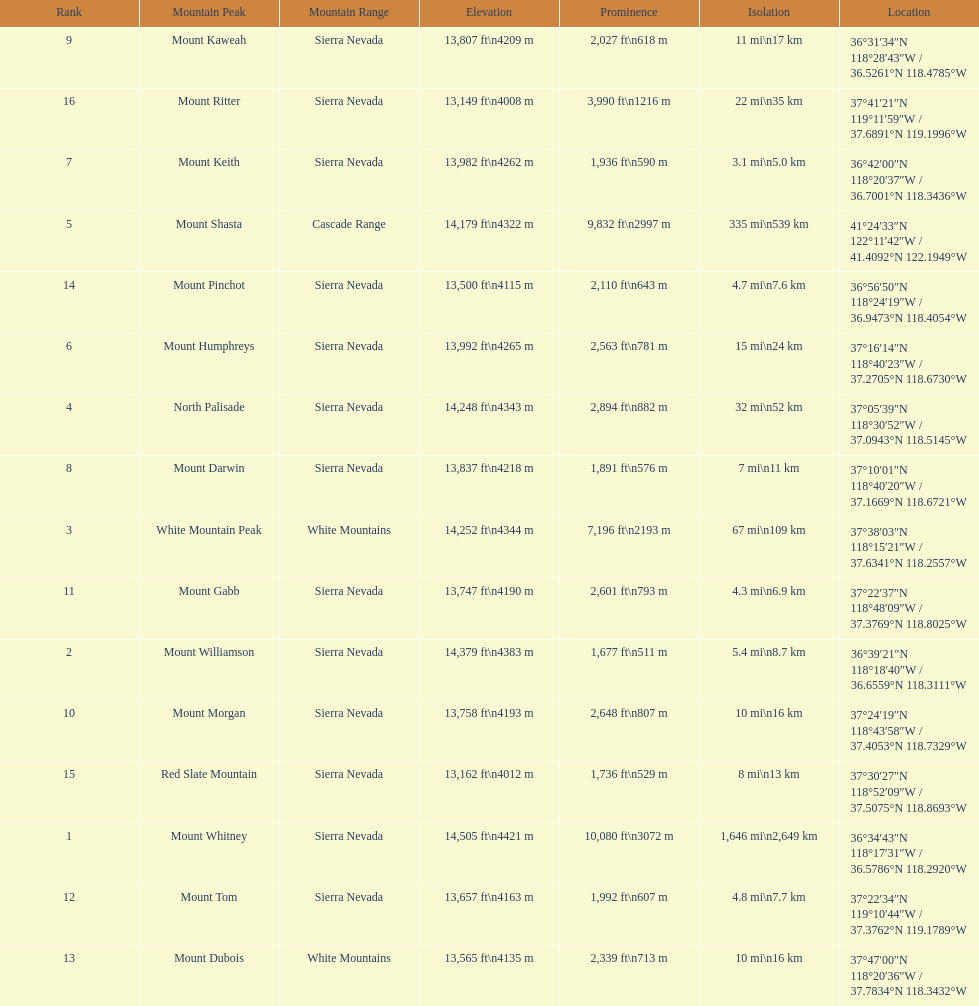Which mountain peak is no higher than 13,149 ft? Mount Ritter. 